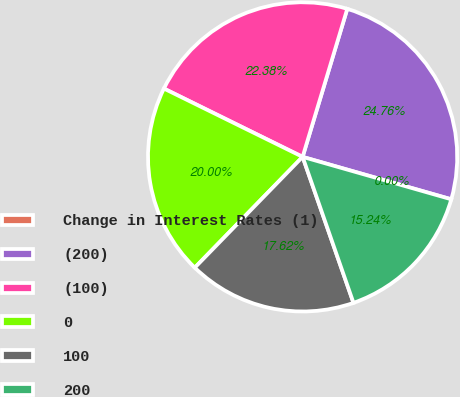Convert chart to OTSL. <chart><loc_0><loc_0><loc_500><loc_500><pie_chart><fcel>Change in Interest Rates (1)<fcel>(200)<fcel>(100)<fcel>0<fcel>100<fcel>200<nl><fcel>0.0%<fcel>24.76%<fcel>22.38%<fcel>20.0%<fcel>17.62%<fcel>15.24%<nl></chart> 